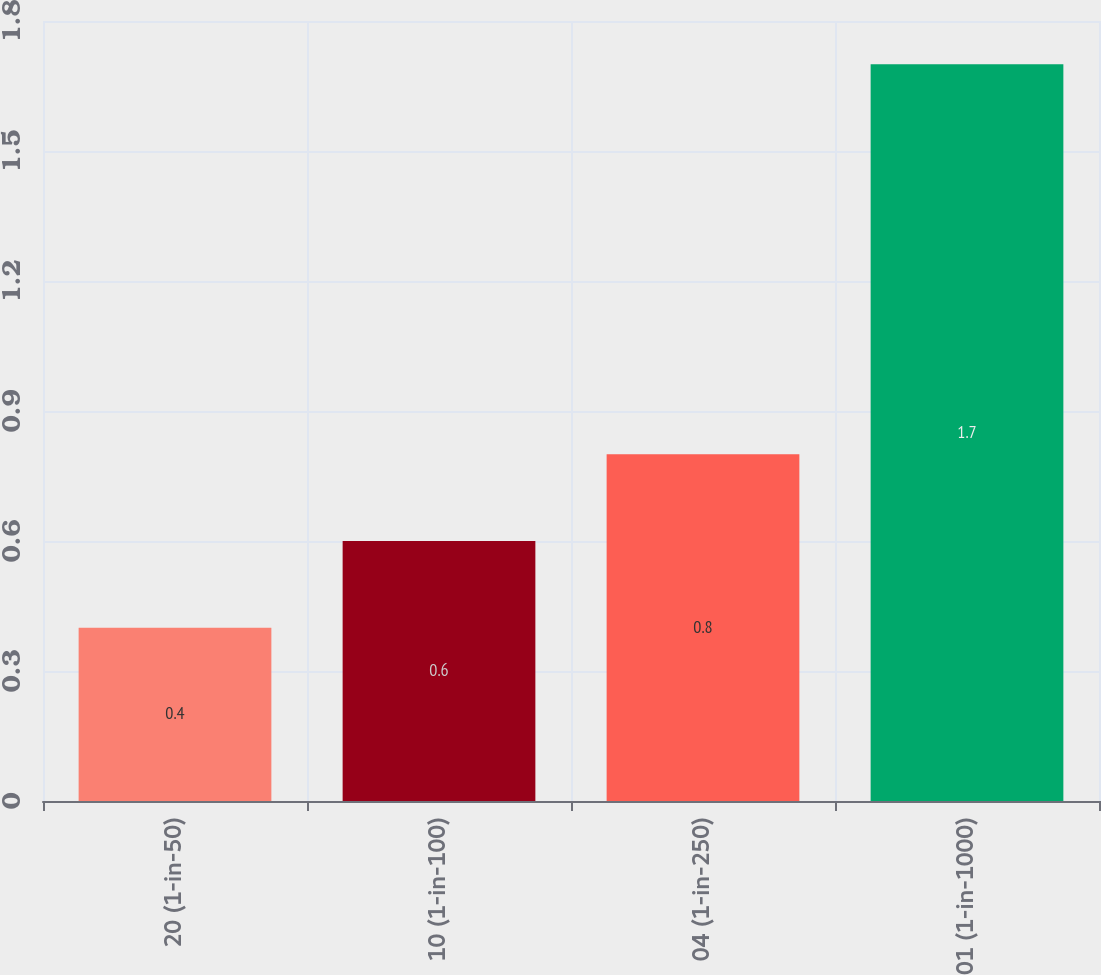<chart> <loc_0><loc_0><loc_500><loc_500><bar_chart><fcel>20 (1-in-50)<fcel>10 (1-in-100)<fcel>04 (1-in-250)<fcel>01 (1-in-1000)<nl><fcel>0.4<fcel>0.6<fcel>0.8<fcel>1.7<nl></chart> 